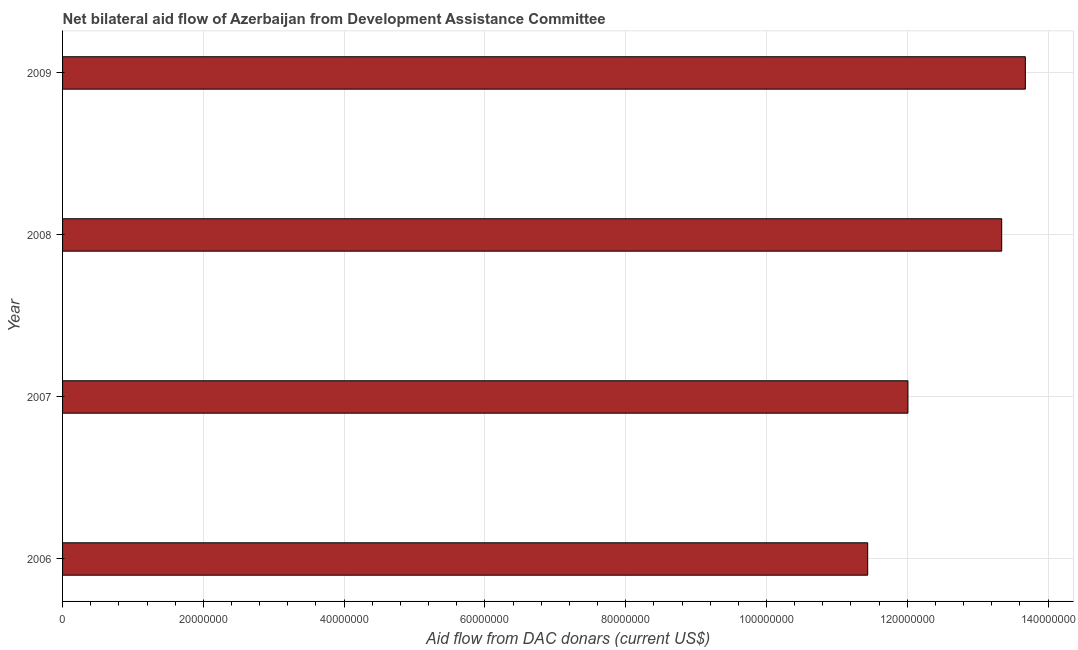Does the graph contain any zero values?
Your answer should be very brief. No. What is the title of the graph?
Provide a short and direct response. Net bilateral aid flow of Azerbaijan from Development Assistance Committee. What is the label or title of the X-axis?
Keep it short and to the point. Aid flow from DAC donars (current US$). What is the net bilateral aid flows from dac donors in 2006?
Ensure brevity in your answer.  1.14e+08. Across all years, what is the maximum net bilateral aid flows from dac donors?
Your answer should be very brief. 1.37e+08. Across all years, what is the minimum net bilateral aid flows from dac donors?
Your answer should be compact. 1.14e+08. In which year was the net bilateral aid flows from dac donors minimum?
Give a very brief answer. 2006. What is the sum of the net bilateral aid flows from dac donors?
Provide a succinct answer. 5.05e+08. What is the difference between the net bilateral aid flows from dac donors in 2007 and 2009?
Make the answer very short. -1.67e+07. What is the average net bilateral aid flows from dac donors per year?
Offer a very short reply. 1.26e+08. What is the median net bilateral aid flows from dac donors?
Ensure brevity in your answer.  1.27e+08. In how many years, is the net bilateral aid flows from dac donors greater than 52000000 US$?
Make the answer very short. 4. Do a majority of the years between 2009 and 2006 (inclusive) have net bilateral aid flows from dac donors greater than 76000000 US$?
Offer a very short reply. Yes. What is the ratio of the net bilateral aid flows from dac donors in 2007 to that in 2008?
Offer a very short reply. 0.9. Is the net bilateral aid flows from dac donors in 2006 less than that in 2008?
Your answer should be compact. Yes. What is the difference between the highest and the second highest net bilateral aid flows from dac donors?
Your answer should be very brief. 3.36e+06. Is the sum of the net bilateral aid flows from dac donors in 2007 and 2009 greater than the maximum net bilateral aid flows from dac donors across all years?
Provide a succinct answer. Yes. What is the difference between the highest and the lowest net bilateral aid flows from dac donors?
Ensure brevity in your answer.  2.24e+07. How many bars are there?
Your answer should be compact. 4. Are all the bars in the graph horizontal?
Offer a very short reply. Yes. How many years are there in the graph?
Offer a terse response. 4. What is the difference between two consecutive major ticks on the X-axis?
Provide a succinct answer. 2.00e+07. What is the Aid flow from DAC donars (current US$) of 2006?
Your answer should be compact. 1.14e+08. What is the Aid flow from DAC donars (current US$) of 2007?
Your answer should be compact. 1.20e+08. What is the Aid flow from DAC donars (current US$) in 2008?
Make the answer very short. 1.33e+08. What is the Aid flow from DAC donars (current US$) of 2009?
Keep it short and to the point. 1.37e+08. What is the difference between the Aid flow from DAC donars (current US$) in 2006 and 2007?
Offer a very short reply. -5.72e+06. What is the difference between the Aid flow from DAC donars (current US$) in 2006 and 2008?
Your response must be concise. -1.90e+07. What is the difference between the Aid flow from DAC donars (current US$) in 2006 and 2009?
Provide a succinct answer. -2.24e+07. What is the difference between the Aid flow from DAC donars (current US$) in 2007 and 2008?
Your answer should be compact. -1.33e+07. What is the difference between the Aid flow from DAC donars (current US$) in 2007 and 2009?
Your answer should be compact. -1.67e+07. What is the difference between the Aid flow from DAC donars (current US$) in 2008 and 2009?
Your answer should be compact. -3.36e+06. What is the ratio of the Aid flow from DAC donars (current US$) in 2006 to that in 2007?
Make the answer very short. 0.95. What is the ratio of the Aid flow from DAC donars (current US$) in 2006 to that in 2008?
Your response must be concise. 0.86. What is the ratio of the Aid flow from DAC donars (current US$) in 2006 to that in 2009?
Offer a very short reply. 0.84. What is the ratio of the Aid flow from DAC donars (current US$) in 2007 to that in 2008?
Provide a short and direct response. 0.9. What is the ratio of the Aid flow from DAC donars (current US$) in 2007 to that in 2009?
Give a very brief answer. 0.88. 